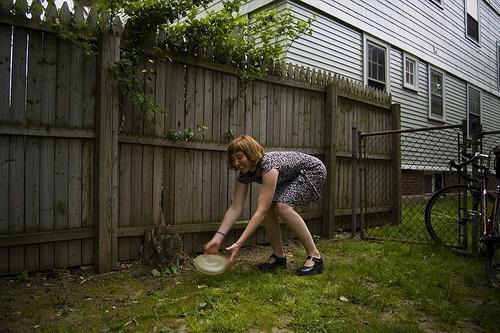How many people are in photo?
Give a very brief answer. 1. 